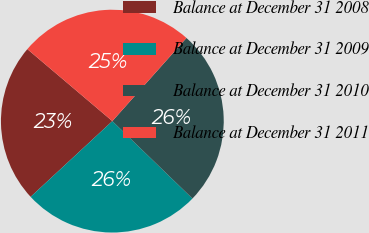Convert chart to OTSL. <chart><loc_0><loc_0><loc_500><loc_500><pie_chart><fcel>Balance at December 31 2008<fcel>Balance at December 31 2009<fcel>Balance at December 31 2010<fcel>Balance at December 31 2011<nl><fcel>23.08%<fcel>25.88%<fcel>25.64%<fcel>25.4%<nl></chart> 